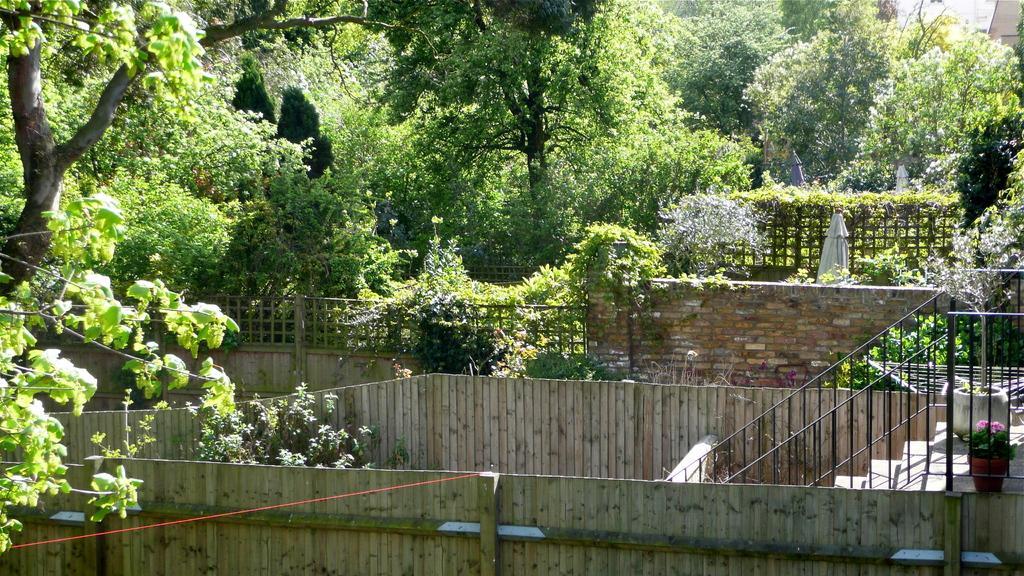How would you summarize this image in a sentence or two? This picture consists of a garden and in the garden I can see trees and staircase and plants and rope and fence ,wall. 